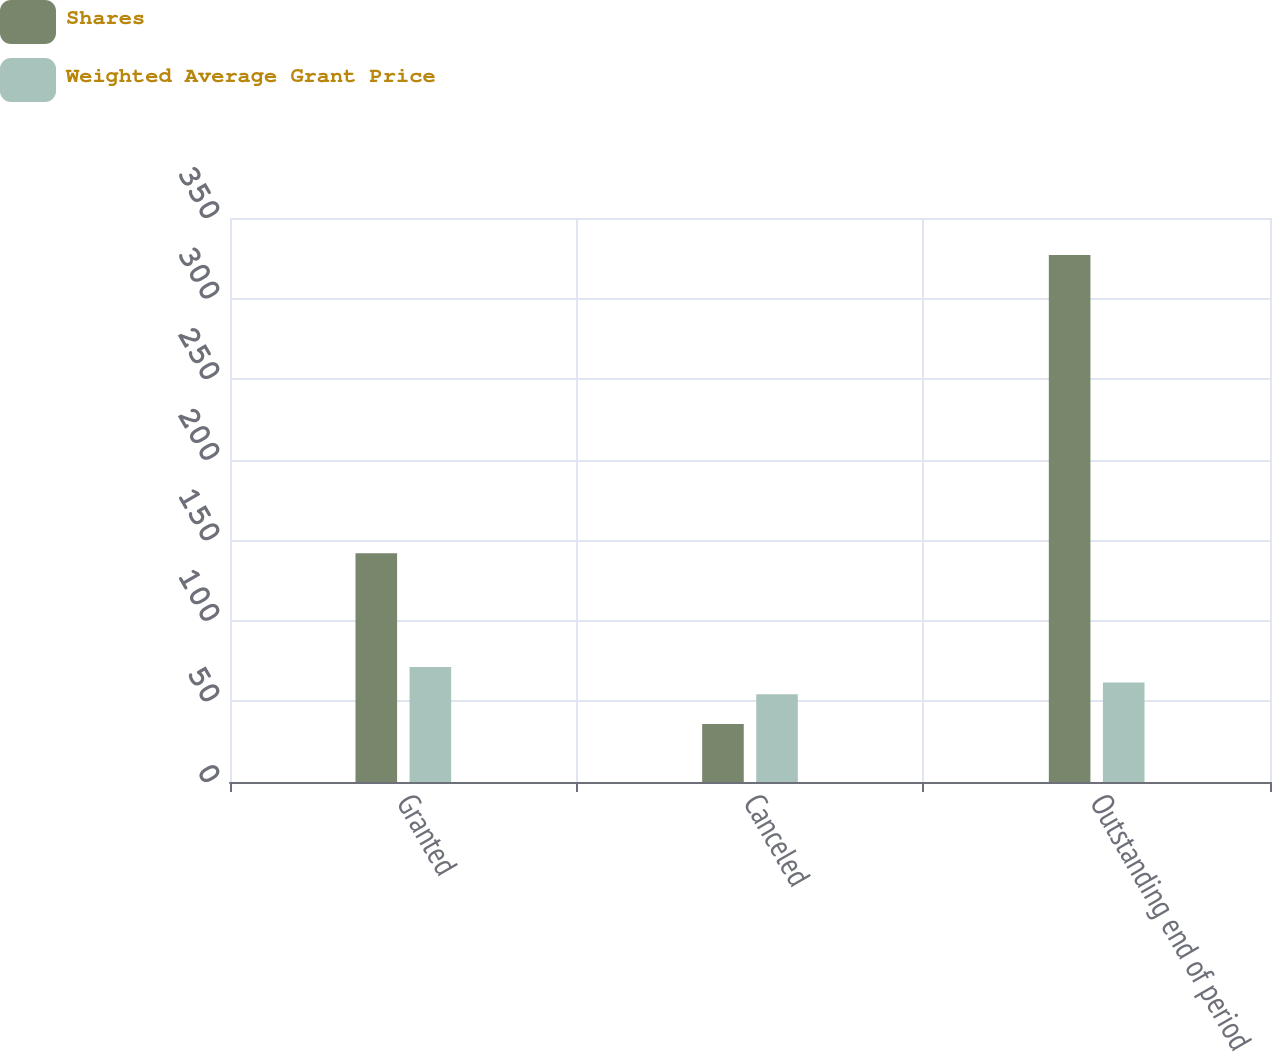Convert chart. <chart><loc_0><loc_0><loc_500><loc_500><stacked_bar_chart><ecel><fcel>Granted<fcel>Canceled<fcel>Outstanding end of period<nl><fcel>Shares<fcel>142<fcel>36<fcel>327<nl><fcel>Weighted Average Grant Price<fcel>71.33<fcel>54.47<fcel>61.79<nl></chart> 